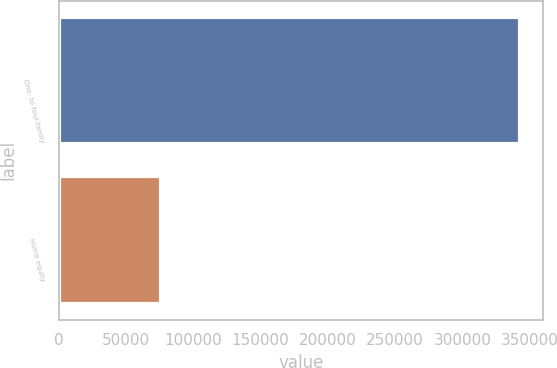Convert chart to OTSL. <chart><loc_0><loc_0><loc_500><loc_500><bar_chart><fcel>One- to four-family<fcel>Home equity<nl><fcel>342971<fcel>76282<nl></chart> 